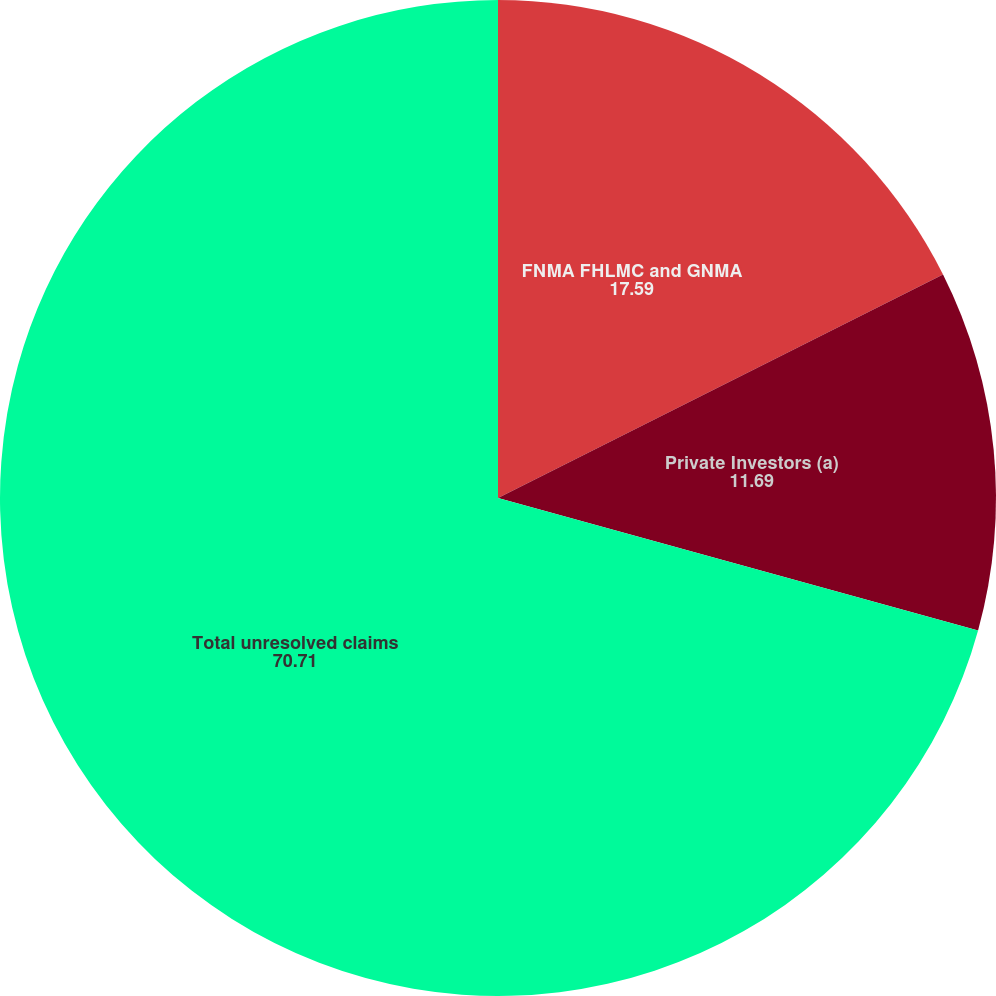<chart> <loc_0><loc_0><loc_500><loc_500><pie_chart><fcel>FNMA FHLMC and GNMA<fcel>Private Investors (a)<fcel>Total unresolved claims<nl><fcel>17.59%<fcel>11.69%<fcel>70.71%<nl></chart> 